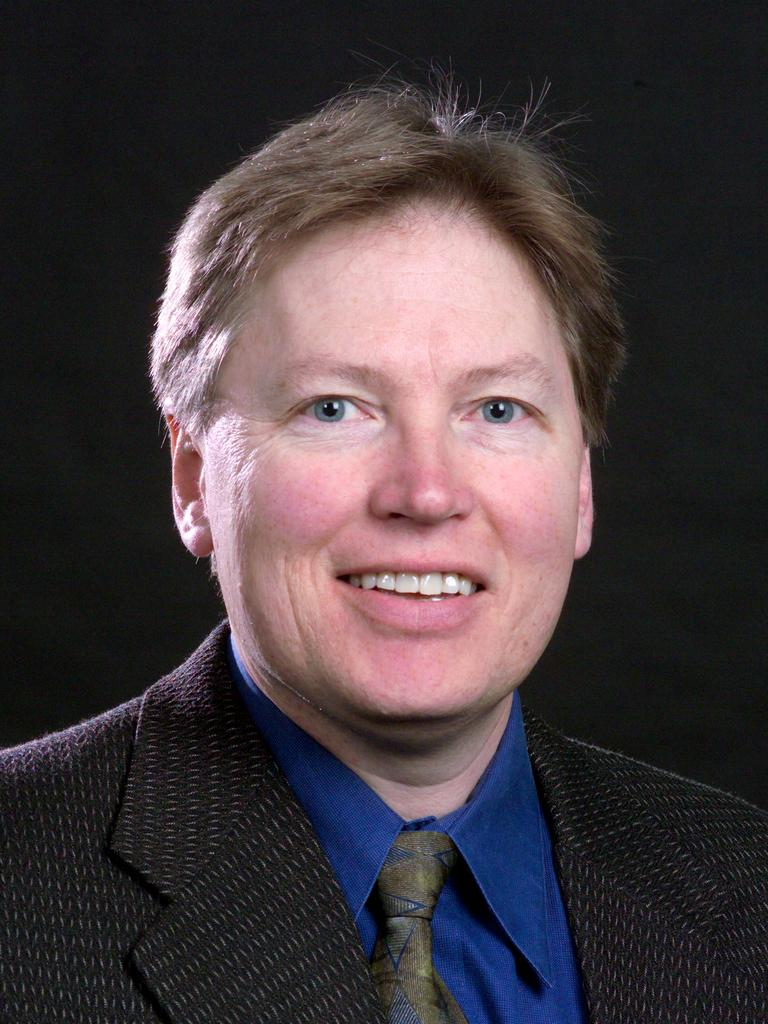What is present in the image? There is a person in the image. How is the person's facial expression? The person is smiling. What type of clothing is the person wearing? The person is wearing a suit. How many sisters does the person have in the image? There is no information about the person's sisters in the image. What type of feet does the person have in the image? There is no information about the person's feet in the image. 